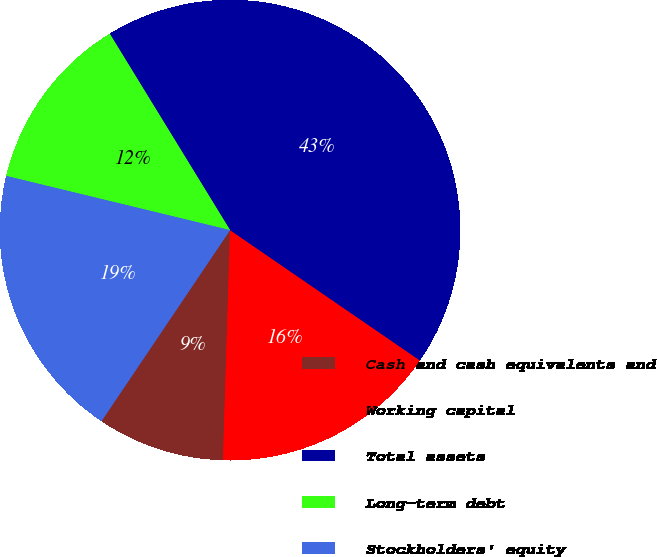Convert chart. <chart><loc_0><loc_0><loc_500><loc_500><pie_chart><fcel>Cash and cash equivalents and<fcel>Working capital<fcel>Total assets<fcel>Long-term debt<fcel>Stockholders' equity<nl><fcel>8.94%<fcel>15.91%<fcel>43.32%<fcel>12.47%<fcel>19.35%<nl></chart> 